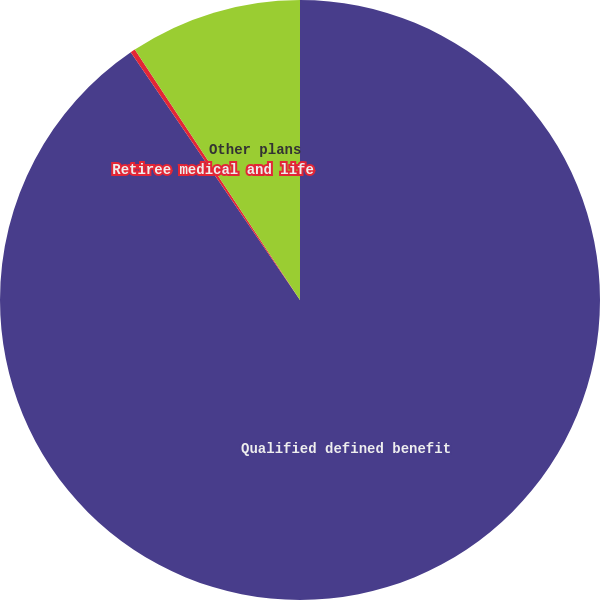Convert chart to OTSL. <chart><loc_0><loc_0><loc_500><loc_500><pie_chart><fcel>Qualified defined benefit<fcel>Retiree medical and life<fcel>Other plans<nl><fcel>90.46%<fcel>0.26%<fcel>9.28%<nl></chart> 